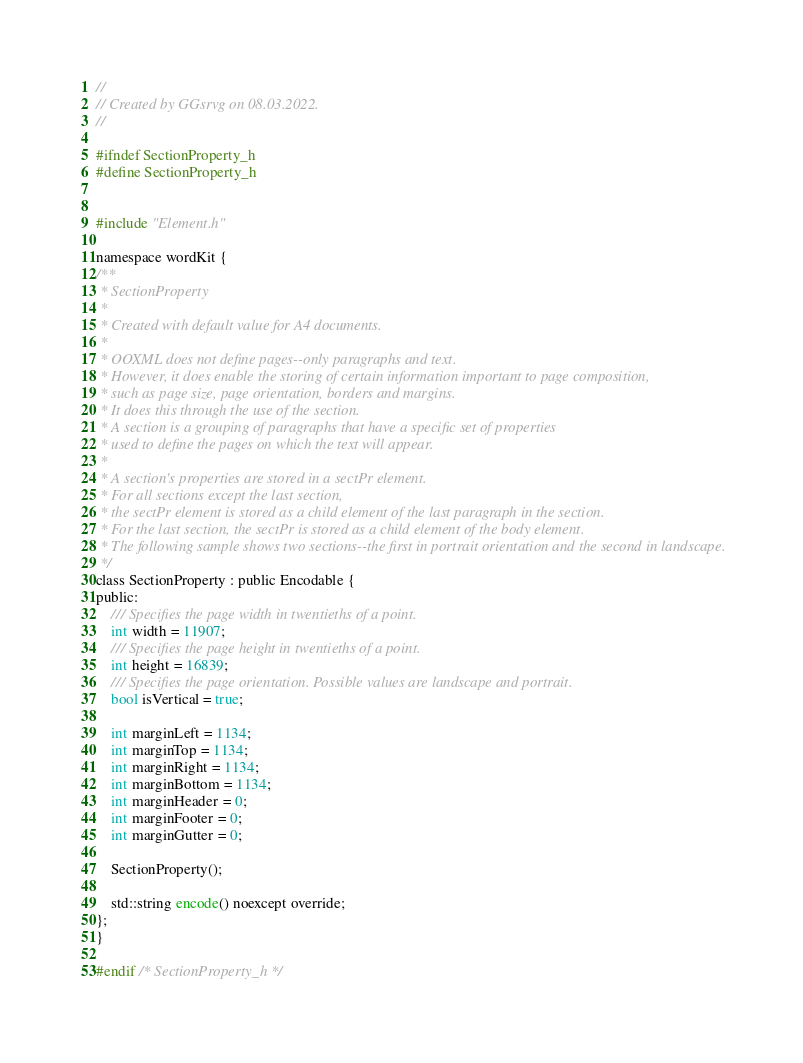<code> <loc_0><loc_0><loc_500><loc_500><_C_>//
// Created by GGsrvg on 08.03.2022.
//

#ifndef SectionProperty_h
#define SectionProperty_h


#include "Element.h"

namespace wordKit {
/**
 * SectionProperty
 *
 * Created with default value for A4 documents.
 *
 * OOXML does not define pages--only paragraphs and text.
 * However, it does enable the storing of certain information important to page composition,
 * such as page size, page orientation, borders and margins.
 * It does this through the use of the section.
 * A section is a grouping of paragraphs that have a specific set of properties
 * used to define the pages on which the text will appear.
 *
 * A section's properties are stored in a sectPr element.
 * For all sections except the last section,
 * the sectPr element is stored as a child element of the last paragraph in the section.
 * For the last section, the sectPr is stored as a child element of the body element.
 * The following sample shows two sections--the first in portrait orientation and the second in landscape.
 */
class SectionProperty : public Encodable {
public:
    /// Specifies the page width in twentieths of a point.
    int width = 11907;
    /// Specifies the page height in twentieths of a point.
    int height = 16839;
    /// Specifies the page orientation. Possible values are landscape and portrait.
    bool isVertical = true;

    int marginLeft = 1134;
    int marginTop = 1134;
    int marginRight = 1134;
    int marginBottom = 1134;
    int marginHeader = 0;
    int marginFooter = 0;
    int marginGutter = 0;

    SectionProperty();

    std::string encode() noexcept override;
};
}

#endif /* SectionProperty_h */
</code> 